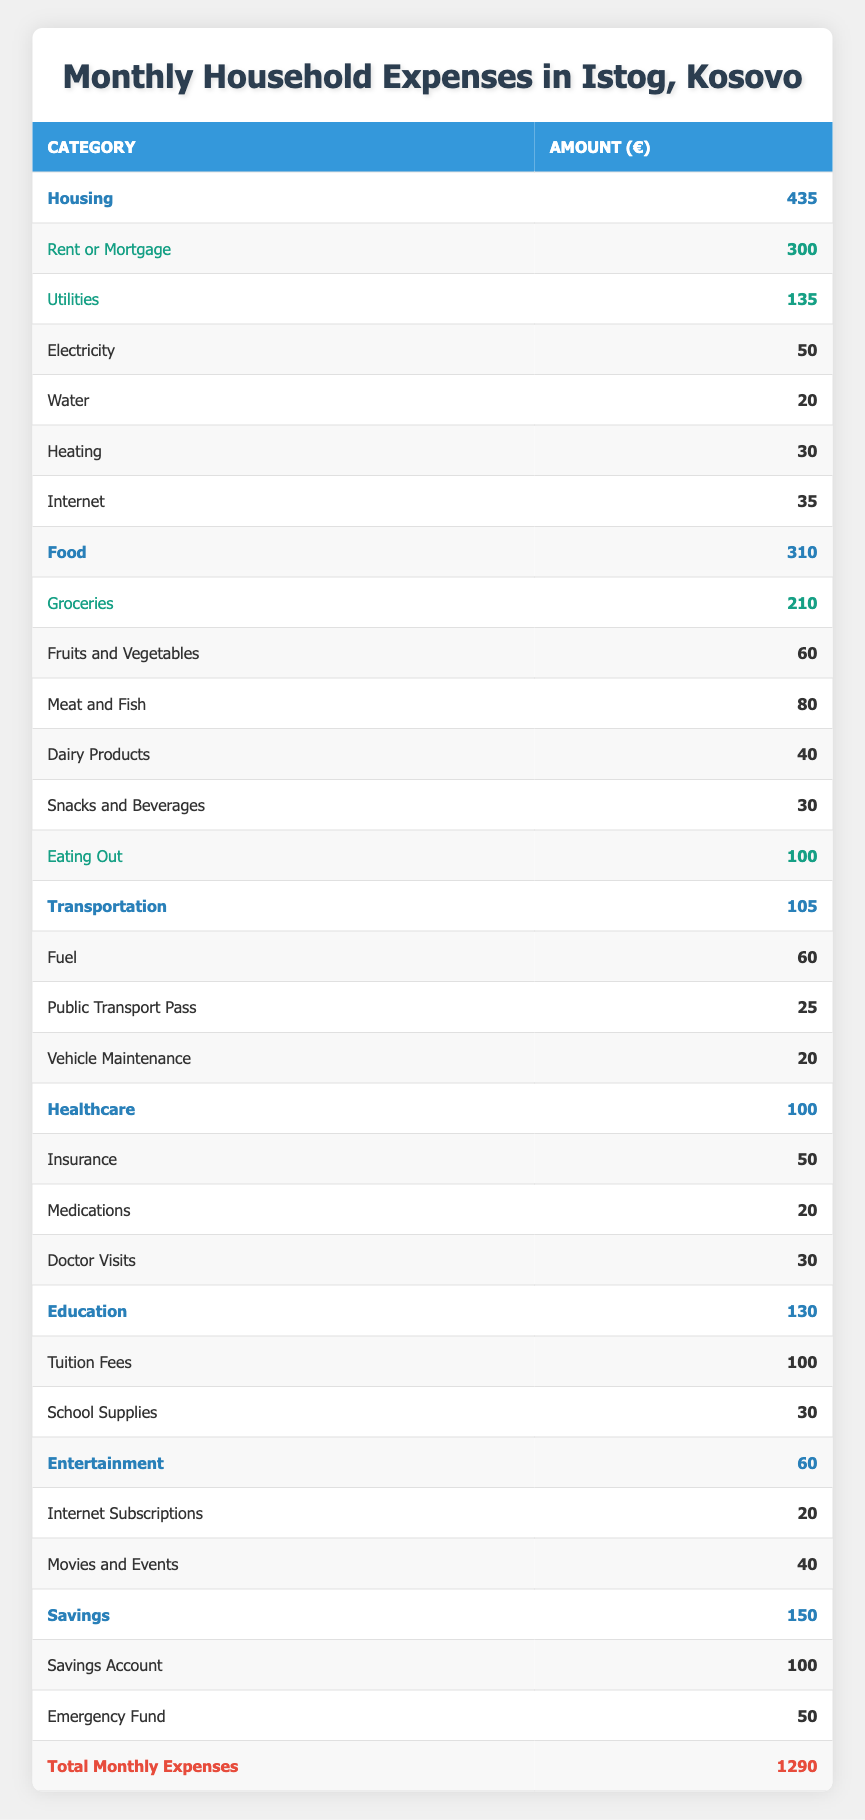What is the total amount spent on housing? The total for housing is given directly under the "Housing" category as 435. This value is the sum of rent or mortgage and utilities.
Answer: 435 What is the amount allocated to groceries? Under the "Food" category, the "Groceries" subcategory specifically states the amount spent on groceries, which is 210.
Answer: 210 Is the amount spent on transportation greater than that spent on healthcare? The transportation expenses total 105, while healthcare expenses total 100. Since 105 is greater than 100, the statement is true.
Answer: Yes What is the total amount spent on utilities? The total for utilities is calculated by adding each sub-item: Electricity (50) + Water (20) + Heating (30) + Internet (35), which equals 135.
Answer: 135 How much more is spent on eating out compared to snacks and beverages? The amount for eating out is 100, while snacks and beverages total 30. So, the difference is 100 - 30 = 70.
Answer: 70 What percentage of the total monthly expenses is allocated to savings? The total monthly expenses are 1290, and savings amounts to 150. The percentage is calculated as (150/1290) * 100, which equals approximately 11.63%.
Answer: 11.63% What is the sum of all healthcare-related expenses? The healthcare expenses total can be calculated by adding Insurance (50) + Medications (20) + Doctor Visits (30), resulting in a total of 100.
Answer: 100 Is the total amount spent on education greater than the total amount spent on entertainment? Education totals 130 and entertainment totals 60. Since 130 is greater than 60, this statement is true.
Answer: Yes How much do families in Istog spend on food and transportation combined? The total for food is 310 and for transportation is 105. The combined total is 310 + 105 = 415.
Answer: 415 